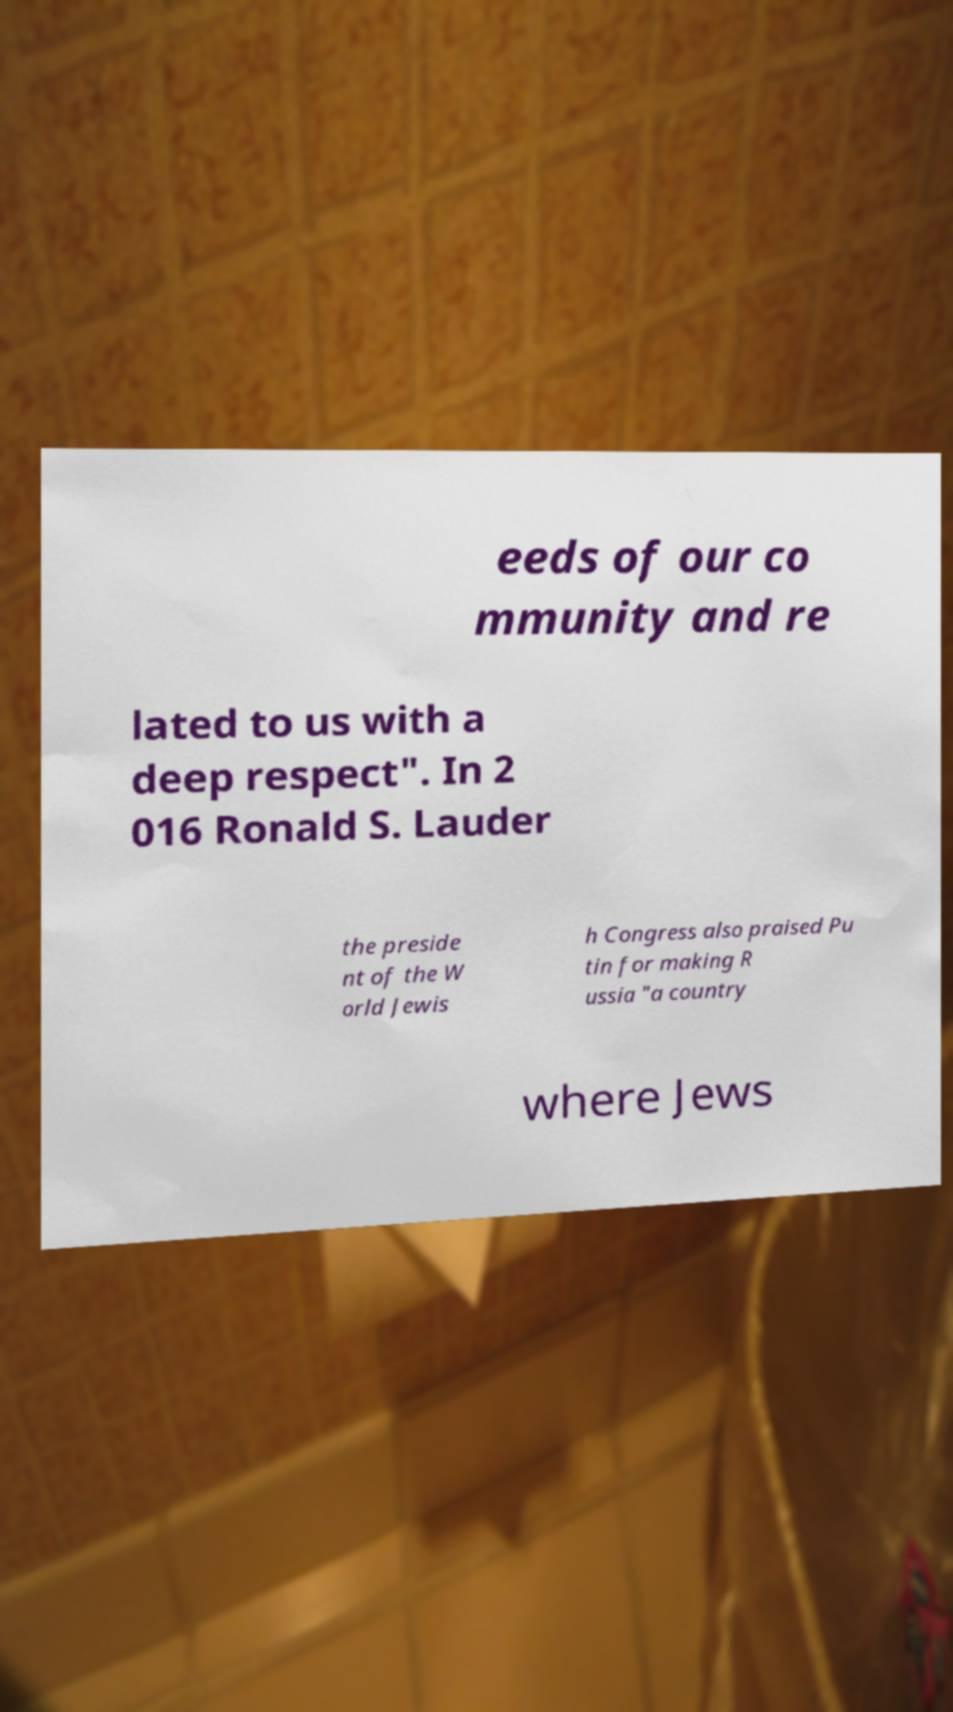Could you extract and type out the text from this image? eeds of our co mmunity and re lated to us with a deep respect". In 2 016 Ronald S. Lauder the preside nt of the W orld Jewis h Congress also praised Pu tin for making R ussia "a country where Jews 